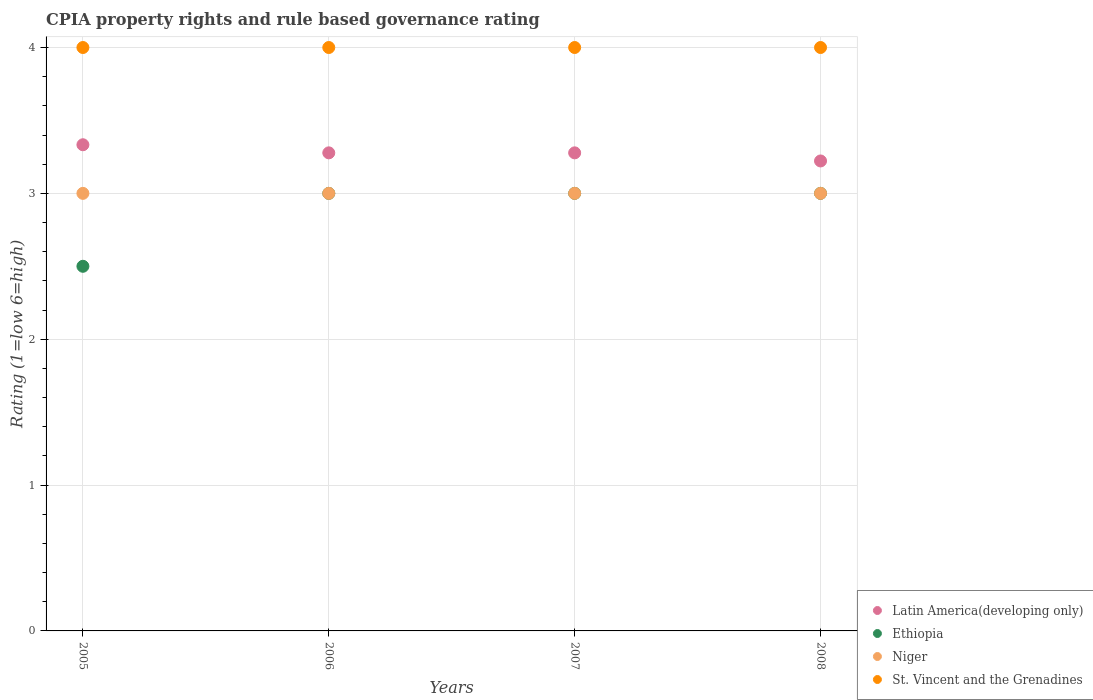Across all years, what is the maximum CPIA rating in Latin America(developing only)?
Your answer should be very brief. 3.33. Across all years, what is the minimum CPIA rating in Latin America(developing only)?
Your answer should be compact. 3.22. In which year was the CPIA rating in Latin America(developing only) minimum?
Your answer should be compact. 2008. What is the total CPIA rating in St. Vincent and the Grenadines in the graph?
Offer a terse response. 16. What is the difference between the CPIA rating in Ethiopia in 2005 and that in 2008?
Offer a very short reply. -0.5. What is the difference between the CPIA rating in Ethiopia in 2006 and the CPIA rating in Niger in 2008?
Provide a short and direct response. 0. What is the average CPIA rating in Ethiopia per year?
Offer a terse response. 2.88. In the year 2006, what is the difference between the CPIA rating in Niger and CPIA rating in Ethiopia?
Provide a short and direct response. 0. What is the ratio of the CPIA rating in Niger in 2005 to that in 2007?
Your answer should be compact. 1. In how many years, is the CPIA rating in Ethiopia greater than the average CPIA rating in Ethiopia taken over all years?
Provide a short and direct response. 3. Is it the case that in every year, the sum of the CPIA rating in Niger and CPIA rating in Latin America(developing only)  is greater than the CPIA rating in Ethiopia?
Your answer should be very brief. Yes. Is the CPIA rating in St. Vincent and the Grenadines strictly greater than the CPIA rating in Latin America(developing only) over the years?
Keep it short and to the point. Yes. How many years are there in the graph?
Make the answer very short. 4. Are the values on the major ticks of Y-axis written in scientific E-notation?
Offer a terse response. No. Does the graph contain any zero values?
Your response must be concise. No. How many legend labels are there?
Your answer should be compact. 4. What is the title of the graph?
Provide a short and direct response. CPIA property rights and rule based governance rating. What is the label or title of the X-axis?
Provide a short and direct response. Years. What is the label or title of the Y-axis?
Provide a short and direct response. Rating (1=low 6=high). What is the Rating (1=low 6=high) of Latin America(developing only) in 2005?
Offer a very short reply. 3.33. What is the Rating (1=low 6=high) of Niger in 2005?
Offer a very short reply. 3. What is the Rating (1=low 6=high) of Latin America(developing only) in 2006?
Ensure brevity in your answer.  3.28. What is the Rating (1=low 6=high) in Niger in 2006?
Keep it short and to the point. 3. What is the Rating (1=low 6=high) of Latin America(developing only) in 2007?
Ensure brevity in your answer.  3.28. What is the Rating (1=low 6=high) of St. Vincent and the Grenadines in 2007?
Ensure brevity in your answer.  4. What is the Rating (1=low 6=high) in Latin America(developing only) in 2008?
Offer a terse response. 3.22. What is the Rating (1=low 6=high) of Ethiopia in 2008?
Offer a terse response. 3. What is the Rating (1=low 6=high) of Niger in 2008?
Ensure brevity in your answer.  3. What is the Rating (1=low 6=high) of St. Vincent and the Grenadines in 2008?
Give a very brief answer. 4. Across all years, what is the maximum Rating (1=low 6=high) of Latin America(developing only)?
Your response must be concise. 3.33. Across all years, what is the maximum Rating (1=low 6=high) of Ethiopia?
Ensure brevity in your answer.  3. Across all years, what is the maximum Rating (1=low 6=high) in Niger?
Your answer should be compact. 3. Across all years, what is the maximum Rating (1=low 6=high) in St. Vincent and the Grenadines?
Offer a very short reply. 4. Across all years, what is the minimum Rating (1=low 6=high) in Latin America(developing only)?
Your response must be concise. 3.22. Across all years, what is the minimum Rating (1=low 6=high) in Ethiopia?
Your answer should be compact. 2.5. Across all years, what is the minimum Rating (1=low 6=high) in Niger?
Keep it short and to the point. 3. Across all years, what is the minimum Rating (1=low 6=high) of St. Vincent and the Grenadines?
Your answer should be compact. 4. What is the total Rating (1=low 6=high) of Latin America(developing only) in the graph?
Make the answer very short. 13.11. What is the total Rating (1=low 6=high) of Niger in the graph?
Provide a succinct answer. 12. What is the difference between the Rating (1=low 6=high) of Latin America(developing only) in 2005 and that in 2006?
Keep it short and to the point. 0.06. What is the difference between the Rating (1=low 6=high) in St. Vincent and the Grenadines in 2005 and that in 2006?
Offer a terse response. 0. What is the difference between the Rating (1=low 6=high) of Latin America(developing only) in 2005 and that in 2007?
Your answer should be compact. 0.06. What is the difference between the Rating (1=low 6=high) in Ethiopia in 2005 and that in 2007?
Give a very brief answer. -0.5. What is the difference between the Rating (1=low 6=high) of Ethiopia in 2005 and that in 2008?
Make the answer very short. -0.5. What is the difference between the Rating (1=low 6=high) of Niger in 2005 and that in 2008?
Offer a very short reply. 0. What is the difference between the Rating (1=low 6=high) of St. Vincent and the Grenadines in 2005 and that in 2008?
Provide a succinct answer. 0. What is the difference between the Rating (1=low 6=high) of Latin America(developing only) in 2006 and that in 2007?
Your answer should be very brief. 0. What is the difference between the Rating (1=low 6=high) of Niger in 2006 and that in 2007?
Your answer should be compact. 0. What is the difference between the Rating (1=low 6=high) in Latin America(developing only) in 2006 and that in 2008?
Offer a very short reply. 0.06. What is the difference between the Rating (1=low 6=high) in Ethiopia in 2006 and that in 2008?
Offer a terse response. 0. What is the difference between the Rating (1=low 6=high) in St. Vincent and the Grenadines in 2006 and that in 2008?
Offer a terse response. 0. What is the difference between the Rating (1=low 6=high) in Latin America(developing only) in 2007 and that in 2008?
Ensure brevity in your answer.  0.06. What is the difference between the Rating (1=low 6=high) of St. Vincent and the Grenadines in 2007 and that in 2008?
Your answer should be very brief. 0. What is the difference between the Rating (1=low 6=high) in Latin America(developing only) in 2005 and the Rating (1=low 6=high) in Niger in 2006?
Offer a terse response. 0.33. What is the difference between the Rating (1=low 6=high) of Latin America(developing only) in 2005 and the Rating (1=low 6=high) of St. Vincent and the Grenadines in 2006?
Provide a succinct answer. -0.67. What is the difference between the Rating (1=low 6=high) in Ethiopia in 2005 and the Rating (1=low 6=high) in St. Vincent and the Grenadines in 2006?
Provide a short and direct response. -1.5. What is the difference between the Rating (1=low 6=high) of Niger in 2005 and the Rating (1=low 6=high) of St. Vincent and the Grenadines in 2006?
Provide a succinct answer. -1. What is the difference between the Rating (1=low 6=high) in Latin America(developing only) in 2005 and the Rating (1=low 6=high) in St. Vincent and the Grenadines in 2007?
Make the answer very short. -0.67. What is the difference between the Rating (1=low 6=high) in Latin America(developing only) in 2005 and the Rating (1=low 6=high) in Ethiopia in 2008?
Offer a terse response. 0.33. What is the difference between the Rating (1=low 6=high) in Latin America(developing only) in 2005 and the Rating (1=low 6=high) in Niger in 2008?
Your answer should be compact. 0.33. What is the difference between the Rating (1=low 6=high) of Ethiopia in 2005 and the Rating (1=low 6=high) of Niger in 2008?
Offer a very short reply. -0.5. What is the difference between the Rating (1=low 6=high) of Ethiopia in 2005 and the Rating (1=low 6=high) of St. Vincent and the Grenadines in 2008?
Ensure brevity in your answer.  -1.5. What is the difference between the Rating (1=low 6=high) in Niger in 2005 and the Rating (1=low 6=high) in St. Vincent and the Grenadines in 2008?
Keep it short and to the point. -1. What is the difference between the Rating (1=low 6=high) of Latin America(developing only) in 2006 and the Rating (1=low 6=high) of Ethiopia in 2007?
Your answer should be compact. 0.28. What is the difference between the Rating (1=low 6=high) in Latin America(developing only) in 2006 and the Rating (1=low 6=high) in Niger in 2007?
Ensure brevity in your answer.  0.28. What is the difference between the Rating (1=low 6=high) in Latin America(developing only) in 2006 and the Rating (1=low 6=high) in St. Vincent and the Grenadines in 2007?
Give a very brief answer. -0.72. What is the difference between the Rating (1=low 6=high) in Ethiopia in 2006 and the Rating (1=low 6=high) in Niger in 2007?
Keep it short and to the point. 0. What is the difference between the Rating (1=low 6=high) of Ethiopia in 2006 and the Rating (1=low 6=high) of St. Vincent and the Grenadines in 2007?
Your response must be concise. -1. What is the difference between the Rating (1=low 6=high) in Latin America(developing only) in 2006 and the Rating (1=low 6=high) in Ethiopia in 2008?
Your answer should be compact. 0.28. What is the difference between the Rating (1=low 6=high) in Latin America(developing only) in 2006 and the Rating (1=low 6=high) in Niger in 2008?
Provide a short and direct response. 0.28. What is the difference between the Rating (1=low 6=high) of Latin America(developing only) in 2006 and the Rating (1=low 6=high) of St. Vincent and the Grenadines in 2008?
Keep it short and to the point. -0.72. What is the difference between the Rating (1=low 6=high) of Latin America(developing only) in 2007 and the Rating (1=low 6=high) of Ethiopia in 2008?
Provide a short and direct response. 0.28. What is the difference between the Rating (1=low 6=high) in Latin America(developing only) in 2007 and the Rating (1=low 6=high) in Niger in 2008?
Keep it short and to the point. 0.28. What is the difference between the Rating (1=low 6=high) of Latin America(developing only) in 2007 and the Rating (1=low 6=high) of St. Vincent and the Grenadines in 2008?
Keep it short and to the point. -0.72. What is the difference between the Rating (1=low 6=high) of Ethiopia in 2007 and the Rating (1=low 6=high) of Niger in 2008?
Offer a terse response. 0. What is the difference between the Rating (1=low 6=high) of Niger in 2007 and the Rating (1=low 6=high) of St. Vincent and the Grenadines in 2008?
Your answer should be very brief. -1. What is the average Rating (1=low 6=high) in Latin America(developing only) per year?
Provide a short and direct response. 3.28. What is the average Rating (1=low 6=high) of Ethiopia per year?
Offer a very short reply. 2.88. What is the average Rating (1=low 6=high) of Niger per year?
Ensure brevity in your answer.  3. In the year 2005, what is the difference between the Rating (1=low 6=high) of Latin America(developing only) and Rating (1=low 6=high) of Niger?
Ensure brevity in your answer.  0.33. In the year 2005, what is the difference between the Rating (1=low 6=high) of Latin America(developing only) and Rating (1=low 6=high) of St. Vincent and the Grenadines?
Give a very brief answer. -0.67. In the year 2005, what is the difference between the Rating (1=low 6=high) in Ethiopia and Rating (1=low 6=high) in Niger?
Provide a short and direct response. -0.5. In the year 2006, what is the difference between the Rating (1=low 6=high) of Latin America(developing only) and Rating (1=low 6=high) of Ethiopia?
Provide a succinct answer. 0.28. In the year 2006, what is the difference between the Rating (1=low 6=high) of Latin America(developing only) and Rating (1=low 6=high) of Niger?
Keep it short and to the point. 0.28. In the year 2006, what is the difference between the Rating (1=low 6=high) of Latin America(developing only) and Rating (1=low 6=high) of St. Vincent and the Grenadines?
Your response must be concise. -0.72. In the year 2006, what is the difference between the Rating (1=low 6=high) in Ethiopia and Rating (1=low 6=high) in Niger?
Your answer should be very brief. 0. In the year 2006, what is the difference between the Rating (1=low 6=high) of Niger and Rating (1=low 6=high) of St. Vincent and the Grenadines?
Ensure brevity in your answer.  -1. In the year 2007, what is the difference between the Rating (1=low 6=high) in Latin America(developing only) and Rating (1=low 6=high) in Ethiopia?
Make the answer very short. 0.28. In the year 2007, what is the difference between the Rating (1=low 6=high) in Latin America(developing only) and Rating (1=low 6=high) in Niger?
Your response must be concise. 0.28. In the year 2007, what is the difference between the Rating (1=low 6=high) of Latin America(developing only) and Rating (1=low 6=high) of St. Vincent and the Grenadines?
Keep it short and to the point. -0.72. In the year 2007, what is the difference between the Rating (1=low 6=high) of Ethiopia and Rating (1=low 6=high) of Niger?
Your response must be concise. 0. In the year 2007, what is the difference between the Rating (1=low 6=high) of Niger and Rating (1=low 6=high) of St. Vincent and the Grenadines?
Keep it short and to the point. -1. In the year 2008, what is the difference between the Rating (1=low 6=high) of Latin America(developing only) and Rating (1=low 6=high) of Ethiopia?
Provide a succinct answer. 0.22. In the year 2008, what is the difference between the Rating (1=low 6=high) of Latin America(developing only) and Rating (1=low 6=high) of Niger?
Offer a terse response. 0.22. In the year 2008, what is the difference between the Rating (1=low 6=high) of Latin America(developing only) and Rating (1=low 6=high) of St. Vincent and the Grenadines?
Keep it short and to the point. -0.78. In the year 2008, what is the difference between the Rating (1=low 6=high) in Ethiopia and Rating (1=low 6=high) in St. Vincent and the Grenadines?
Make the answer very short. -1. In the year 2008, what is the difference between the Rating (1=low 6=high) of Niger and Rating (1=low 6=high) of St. Vincent and the Grenadines?
Provide a succinct answer. -1. What is the ratio of the Rating (1=low 6=high) in Latin America(developing only) in 2005 to that in 2006?
Give a very brief answer. 1.02. What is the ratio of the Rating (1=low 6=high) of Ethiopia in 2005 to that in 2006?
Make the answer very short. 0.83. What is the ratio of the Rating (1=low 6=high) of Niger in 2005 to that in 2006?
Ensure brevity in your answer.  1. What is the ratio of the Rating (1=low 6=high) of Latin America(developing only) in 2005 to that in 2007?
Ensure brevity in your answer.  1.02. What is the ratio of the Rating (1=low 6=high) in Niger in 2005 to that in 2007?
Make the answer very short. 1. What is the ratio of the Rating (1=low 6=high) of Latin America(developing only) in 2005 to that in 2008?
Ensure brevity in your answer.  1.03. What is the ratio of the Rating (1=low 6=high) in Ethiopia in 2005 to that in 2008?
Provide a succinct answer. 0.83. What is the ratio of the Rating (1=low 6=high) of Niger in 2005 to that in 2008?
Provide a short and direct response. 1. What is the ratio of the Rating (1=low 6=high) in Latin America(developing only) in 2006 to that in 2007?
Keep it short and to the point. 1. What is the ratio of the Rating (1=low 6=high) in Niger in 2006 to that in 2007?
Offer a very short reply. 1. What is the ratio of the Rating (1=low 6=high) in St. Vincent and the Grenadines in 2006 to that in 2007?
Make the answer very short. 1. What is the ratio of the Rating (1=low 6=high) in Latin America(developing only) in 2006 to that in 2008?
Your answer should be compact. 1.02. What is the ratio of the Rating (1=low 6=high) in Ethiopia in 2006 to that in 2008?
Offer a terse response. 1. What is the ratio of the Rating (1=low 6=high) of St. Vincent and the Grenadines in 2006 to that in 2008?
Make the answer very short. 1. What is the ratio of the Rating (1=low 6=high) of Latin America(developing only) in 2007 to that in 2008?
Offer a very short reply. 1.02. What is the ratio of the Rating (1=low 6=high) in Niger in 2007 to that in 2008?
Provide a short and direct response. 1. What is the difference between the highest and the second highest Rating (1=low 6=high) in Latin America(developing only)?
Give a very brief answer. 0.06. What is the difference between the highest and the second highest Rating (1=low 6=high) of Niger?
Provide a short and direct response. 0. 